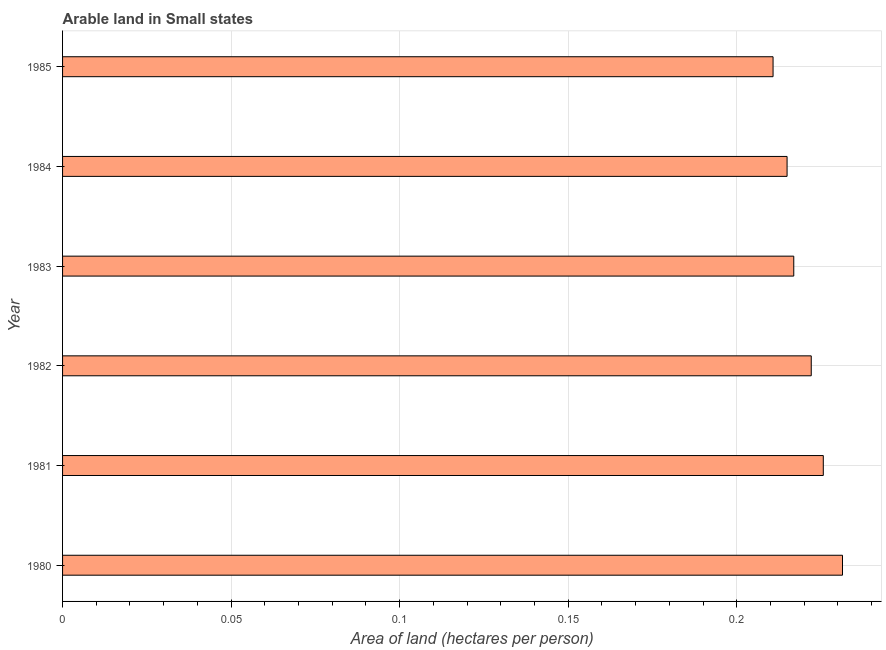What is the title of the graph?
Your answer should be compact. Arable land in Small states. What is the label or title of the X-axis?
Your answer should be very brief. Area of land (hectares per person). What is the label or title of the Y-axis?
Give a very brief answer. Year. What is the area of arable land in 1983?
Provide a succinct answer. 0.22. Across all years, what is the maximum area of arable land?
Your response must be concise. 0.23. Across all years, what is the minimum area of arable land?
Keep it short and to the point. 0.21. In which year was the area of arable land minimum?
Ensure brevity in your answer.  1985. What is the sum of the area of arable land?
Your response must be concise. 1.32. What is the difference between the area of arable land in 1981 and 1982?
Give a very brief answer. 0. What is the average area of arable land per year?
Make the answer very short. 0.22. What is the median area of arable land?
Provide a short and direct response. 0.22. In how many years, is the area of arable land greater than 0.07 hectares per person?
Offer a terse response. 6. Do a majority of the years between 1980 and 1981 (inclusive) have area of arable land greater than 0.19 hectares per person?
Provide a succinct answer. Yes. What is the ratio of the area of arable land in 1982 to that in 1985?
Give a very brief answer. 1.05. Is the area of arable land in 1980 less than that in 1984?
Your answer should be compact. No. What is the difference between the highest and the second highest area of arable land?
Provide a short and direct response. 0.01. In how many years, is the area of arable land greater than the average area of arable land taken over all years?
Provide a short and direct response. 3. How many bars are there?
Make the answer very short. 6. Are all the bars in the graph horizontal?
Provide a succinct answer. Yes. Are the values on the major ticks of X-axis written in scientific E-notation?
Ensure brevity in your answer.  No. What is the Area of land (hectares per person) of 1980?
Your answer should be compact. 0.23. What is the Area of land (hectares per person) in 1981?
Ensure brevity in your answer.  0.23. What is the Area of land (hectares per person) in 1982?
Provide a short and direct response. 0.22. What is the Area of land (hectares per person) of 1983?
Ensure brevity in your answer.  0.22. What is the Area of land (hectares per person) in 1984?
Keep it short and to the point. 0.21. What is the Area of land (hectares per person) in 1985?
Offer a very short reply. 0.21. What is the difference between the Area of land (hectares per person) in 1980 and 1981?
Provide a succinct answer. 0.01. What is the difference between the Area of land (hectares per person) in 1980 and 1982?
Offer a terse response. 0.01. What is the difference between the Area of land (hectares per person) in 1980 and 1983?
Your answer should be very brief. 0.01. What is the difference between the Area of land (hectares per person) in 1980 and 1984?
Make the answer very short. 0.02. What is the difference between the Area of land (hectares per person) in 1980 and 1985?
Your response must be concise. 0.02. What is the difference between the Area of land (hectares per person) in 1981 and 1982?
Keep it short and to the point. 0. What is the difference between the Area of land (hectares per person) in 1981 and 1983?
Keep it short and to the point. 0.01. What is the difference between the Area of land (hectares per person) in 1981 and 1984?
Ensure brevity in your answer.  0.01. What is the difference between the Area of land (hectares per person) in 1981 and 1985?
Offer a terse response. 0.01. What is the difference between the Area of land (hectares per person) in 1982 and 1983?
Your response must be concise. 0.01. What is the difference between the Area of land (hectares per person) in 1982 and 1984?
Your answer should be compact. 0.01. What is the difference between the Area of land (hectares per person) in 1982 and 1985?
Make the answer very short. 0.01. What is the difference between the Area of land (hectares per person) in 1983 and 1984?
Your answer should be compact. 0. What is the difference between the Area of land (hectares per person) in 1983 and 1985?
Give a very brief answer. 0.01. What is the difference between the Area of land (hectares per person) in 1984 and 1985?
Offer a terse response. 0. What is the ratio of the Area of land (hectares per person) in 1980 to that in 1982?
Your answer should be very brief. 1.04. What is the ratio of the Area of land (hectares per person) in 1980 to that in 1983?
Provide a succinct answer. 1.07. What is the ratio of the Area of land (hectares per person) in 1980 to that in 1984?
Keep it short and to the point. 1.08. What is the ratio of the Area of land (hectares per person) in 1980 to that in 1985?
Offer a very short reply. 1.1. What is the ratio of the Area of land (hectares per person) in 1981 to that in 1982?
Provide a short and direct response. 1.02. What is the ratio of the Area of land (hectares per person) in 1981 to that in 1985?
Offer a terse response. 1.07. What is the ratio of the Area of land (hectares per person) in 1982 to that in 1984?
Offer a very short reply. 1.03. What is the ratio of the Area of land (hectares per person) in 1982 to that in 1985?
Offer a terse response. 1.05. What is the ratio of the Area of land (hectares per person) in 1983 to that in 1984?
Provide a succinct answer. 1.01. What is the ratio of the Area of land (hectares per person) in 1983 to that in 1985?
Give a very brief answer. 1.03. What is the ratio of the Area of land (hectares per person) in 1984 to that in 1985?
Your answer should be very brief. 1.02. 